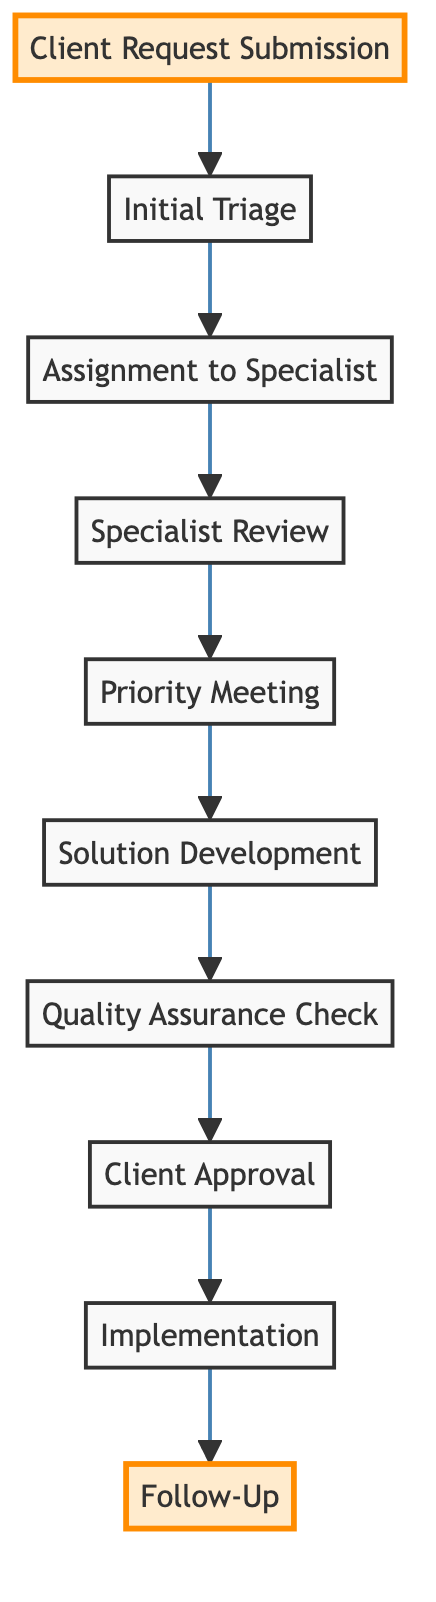What is the first step of the workflow? The first step in the workflow is "Client Request Submission," which is located at the bottom of the diagram.
Answer: Client Request Submission How many steps are there in the workflow? By counting each of the steps from "Client Request Submission" to "Follow-Up," there are ten distinct steps.
Answer: 10 Which node comes immediately after "Quality Assurance Check"? The node that follows "Quality Assurance Check" is "Client Approval," representing the next stage in the process after the quality assurance has been completed.
Answer: Client Approval What is the last step of the workflow? The last step in the workflow is "Follow-Up," which is positioned at the top of the diagram.
Answer: Follow-Up What happens after "Specialist Review"? After "Specialist Review," the process flows to "Priority Meeting," indicating the next action required in response to the review performed by the specialist.
Answer: Priority Meeting Which step involves the involvement of a client? "Priority Meeting" is the step where involvement of the client occurs as the specialist arranges a meeting to confirm details and set expectations.
Answer: Priority Meeting How does the workflow ensure that the client is satisfied? The workflow ensures client satisfaction through the "Follow-Up" step, which is specifically designed to gather feedback and confirm the client's contentment with the implemented solution.
Answer: Follow-Up What is the relationship between "Implementation" and "Client Approval"? "Implementation" takes place after "Client Approval," signifying that the solution is only executed once the client has approved it, establishing a direct dependency of "Implementation" on "Client Approval."
Answer: Implementation follows Client Approval Which step directly precedes "Solution Development"? The step that comes immediately before "Solution Development" is "Priority Meeting," indicating that the meeting with the client is necessary to finalize the details before developing the solution.
Answer: Priority Meeting 